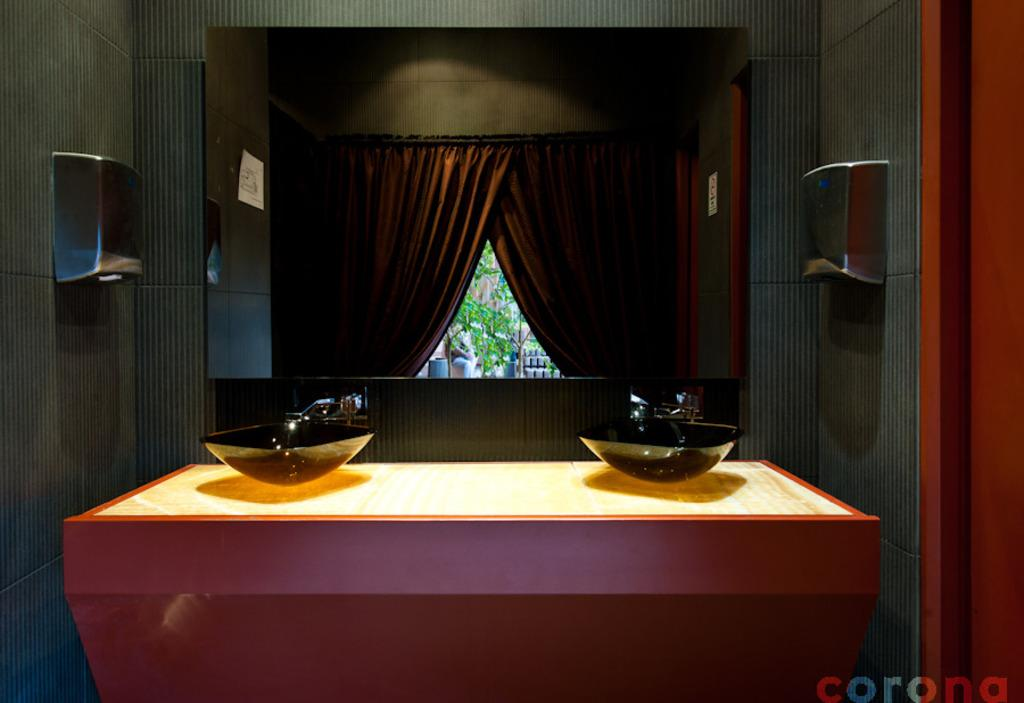What type of space is depicted in the image? There is a room in the image. What piece of furniture is present in the room? There is a table in the room. How many bowls are on the table? There are two bowls on the table. What type of window treatment is visible in the image? There is a curtain visible in the image. What architectural feature can be seen in the image? There is a wall visible in the image. What type of cable is being used by the bears to climb the wall in the image? There are no bears or cables present in the image. What reward is being offered to the person who finds the hidden treasure in the image? There is no mention of a hidden treasure or a reward in the image. 